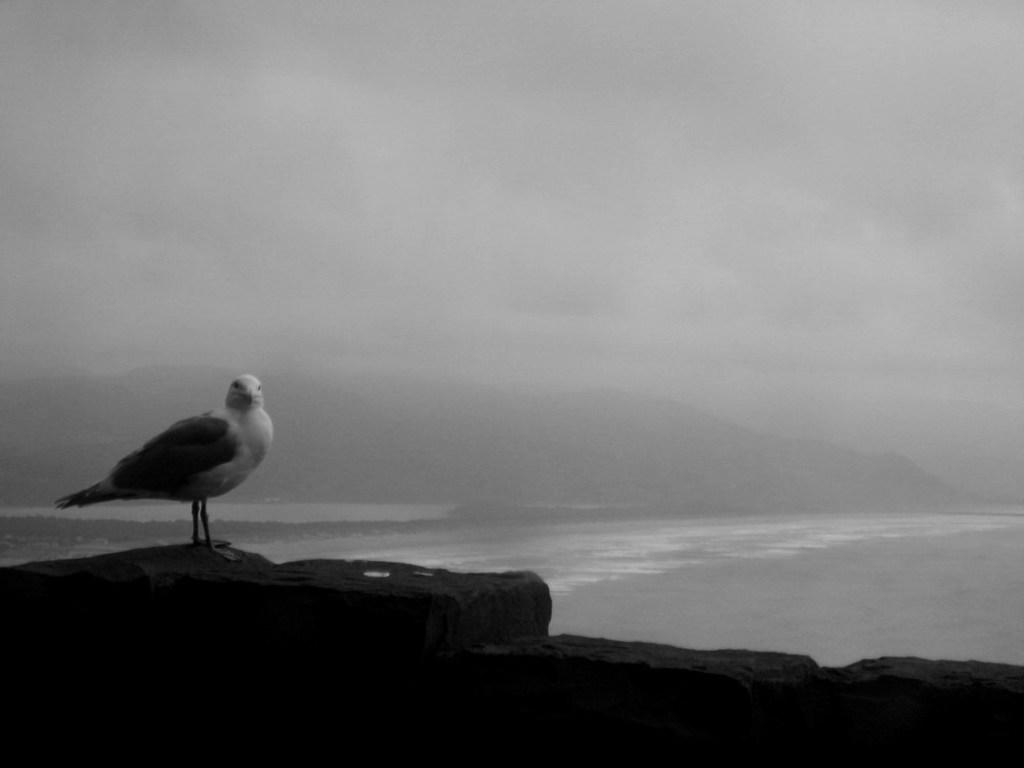What type of animal can be seen in the image? There is a bird in the image. What is the bird situated in? The bird is situated in water. What can be seen in the background of the image? The sky is visible in the background of the image. How many copies of the house are visible in the image? There is no house present in the image. What type of drop can be seen falling from the bird in the image? There is no drop falling from the bird in the image. 